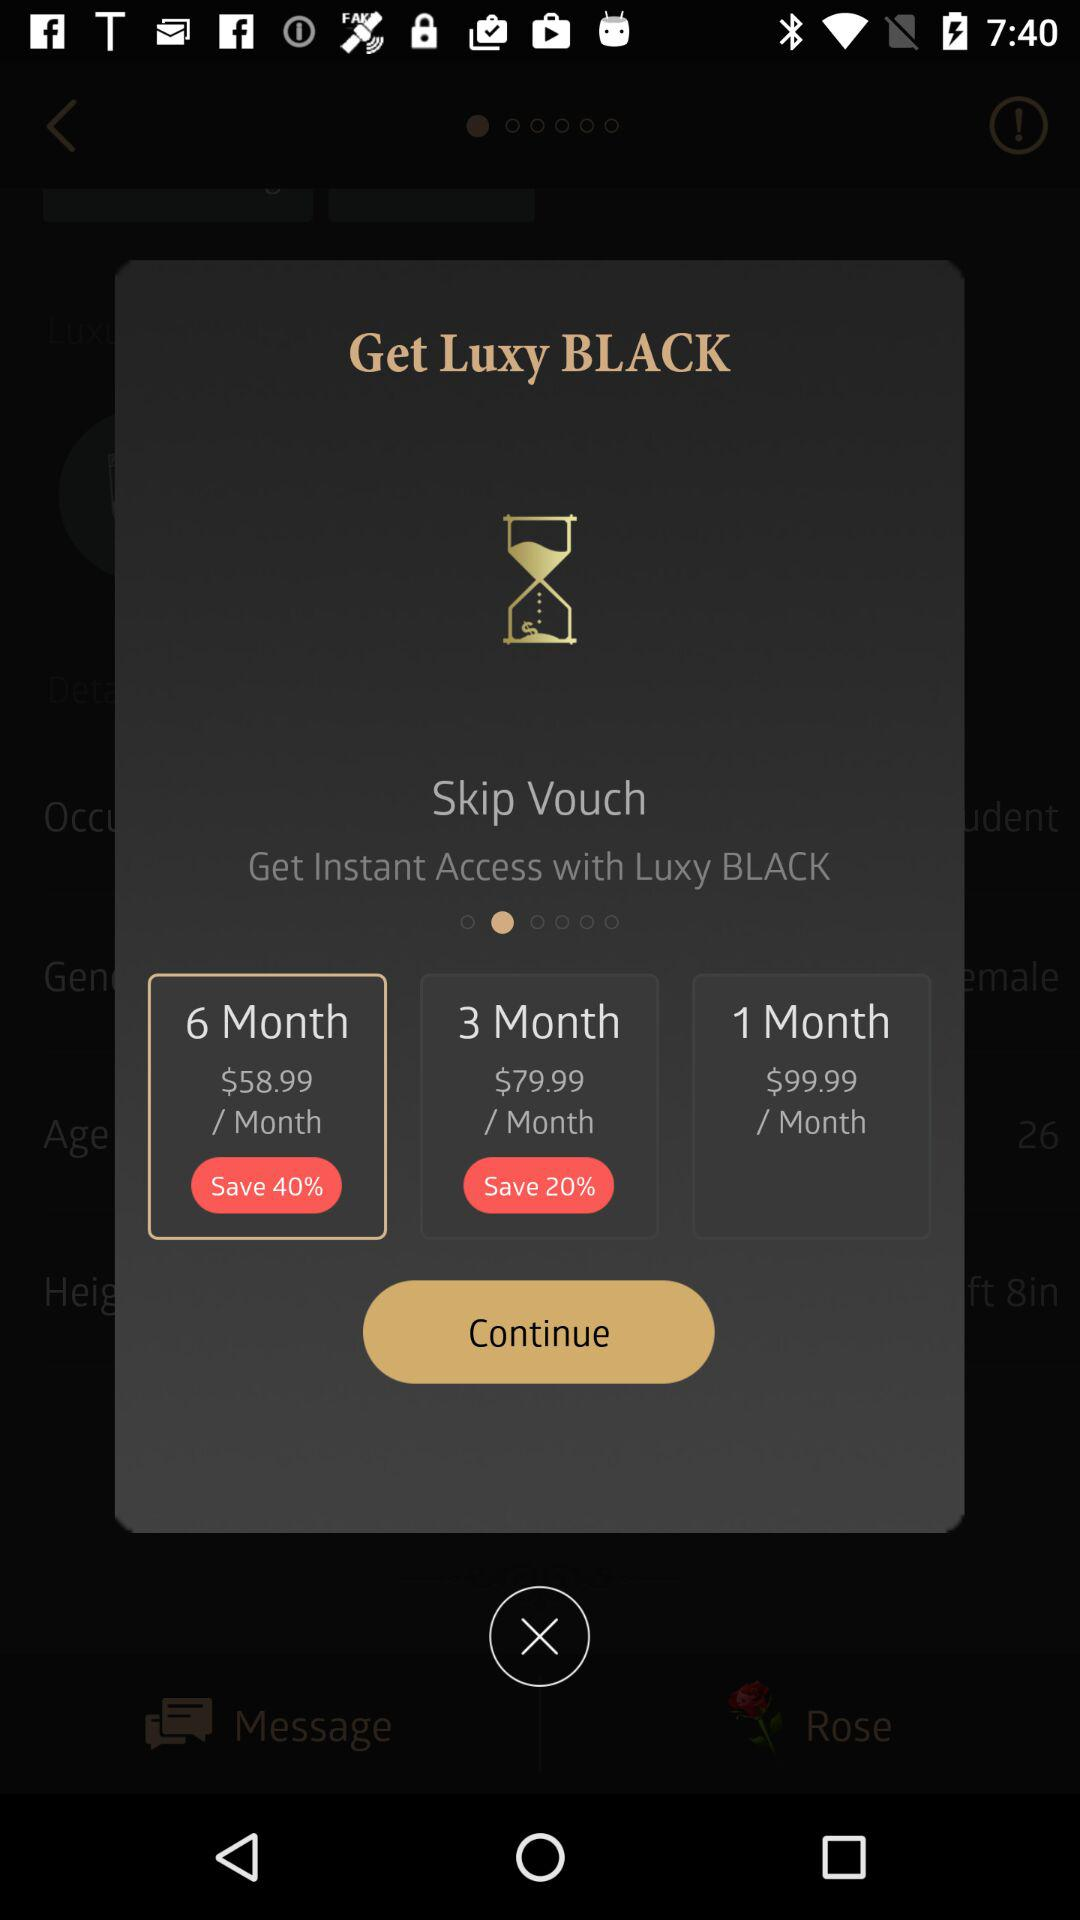How much does a 6-month subscription cost per month? A 6-month subscription cost per month is $58.99. 